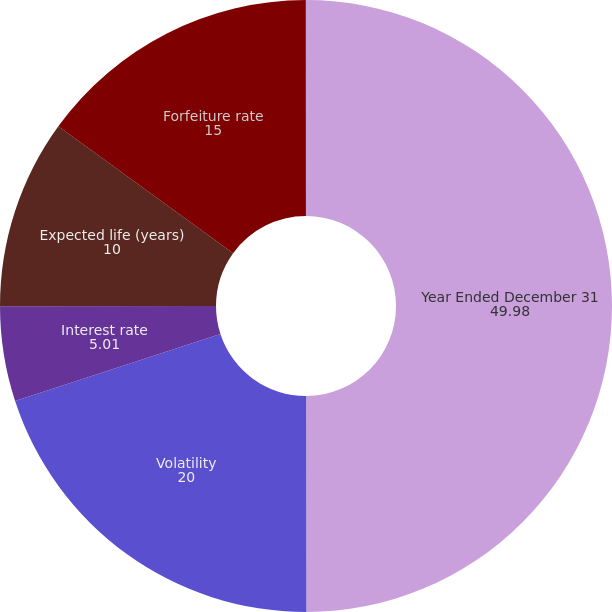<chart> <loc_0><loc_0><loc_500><loc_500><pie_chart><fcel>Year Ended December 31<fcel>Volatility<fcel>Interest rate<fcel>Expected life (years)<fcel>Forfeiture rate<fcel>Dividend yield<nl><fcel>49.98%<fcel>20.0%<fcel>5.01%<fcel>10.0%<fcel>15.0%<fcel>0.01%<nl></chart> 